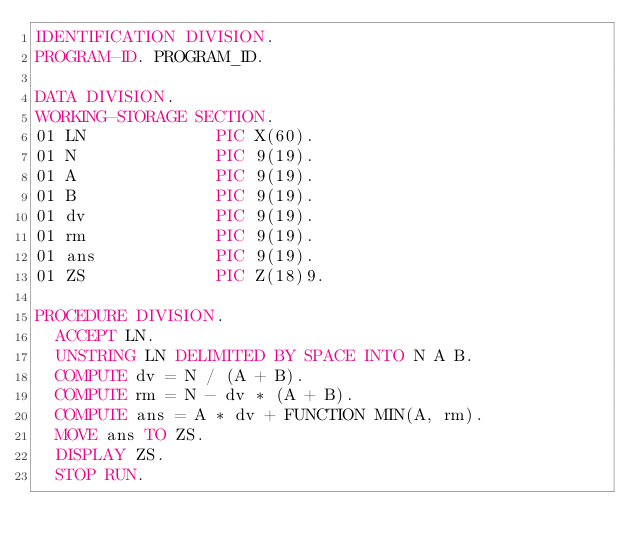Convert code to text. <code><loc_0><loc_0><loc_500><loc_500><_COBOL_>IDENTIFICATION DIVISION.
PROGRAM-ID. PROGRAM_ID.

DATA DIVISION.
WORKING-STORAGE SECTION.
01 LN             PIC X(60).
01 N              PIC 9(19).
01 A              PIC 9(19).
01 B              PIC 9(19).
01 dv             PIC 9(19).
01 rm             PIC 9(19).
01 ans            PIC 9(19).
01 ZS             PIC Z(18)9.

PROCEDURE DIVISION.
  ACCEPT LN.
  UNSTRING LN DELIMITED BY SPACE INTO N A B.
  COMPUTE dv = N / (A + B).
  COMPUTE rm = N - dv * (A + B).
  COMPUTE ans = A * dv + FUNCTION MIN(A, rm).
  MOVE ans TO ZS.
  DISPLAY ZS.
  STOP RUN.
</code> 